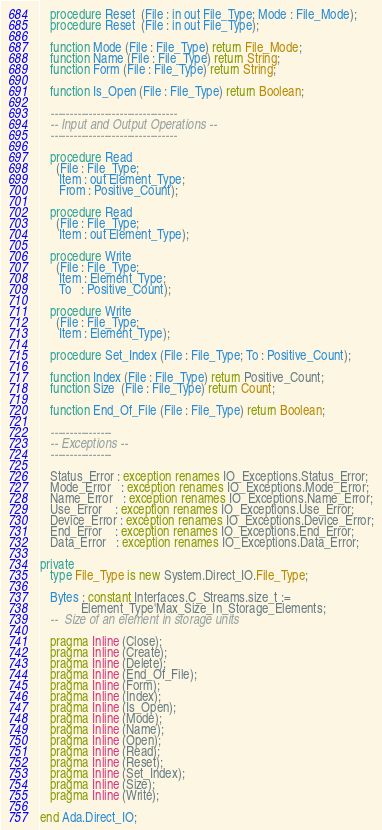<code> <loc_0><loc_0><loc_500><loc_500><_Ada_>   procedure Reset  (File : in out File_Type; Mode : File_Mode);
   procedure Reset  (File : in out File_Type);

   function Mode (File : File_Type) return File_Mode;
   function Name (File : File_Type) return String;
   function Form (File : File_Type) return String;

   function Is_Open (File : File_Type) return Boolean;

   ---------------------------------
   -- Input and Output Operations --
   ---------------------------------

   procedure Read
     (File : File_Type;
      Item : out Element_Type;
      From : Positive_Count);

   procedure Read
     (File : File_Type;
      Item : out Element_Type);

   procedure Write
     (File : File_Type;
      Item : Element_Type;
      To   : Positive_Count);

   procedure Write
     (File : File_Type;
      Item : Element_Type);

   procedure Set_Index (File : File_Type; To : Positive_Count);

   function Index (File : File_Type) return Positive_Count;
   function Size  (File : File_Type) return Count;

   function End_Of_File (File : File_Type) return Boolean;

   ----------------
   -- Exceptions --
   ----------------

   Status_Error : exception renames IO_Exceptions.Status_Error;
   Mode_Error   : exception renames IO_Exceptions.Mode_Error;
   Name_Error   : exception renames IO_Exceptions.Name_Error;
   Use_Error    : exception renames IO_Exceptions.Use_Error;
   Device_Error : exception renames IO_Exceptions.Device_Error;
   End_Error    : exception renames IO_Exceptions.End_Error;
   Data_Error   : exception renames IO_Exceptions.Data_Error;

private
   type File_Type is new System.Direct_IO.File_Type;

   Bytes : constant Interfaces.C_Streams.size_t :=
             Element_Type'Max_Size_In_Storage_Elements;
   --  Size of an element in storage units

   pragma Inline (Close);
   pragma Inline (Create);
   pragma Inline (Delete);
   pragma Inline (End_Of_File);
   pragma Inline (Form);
   pragma Inline (Index);
   pragma Inline (Is_Open);
   pragma Inline (Mode);
   pragma Inline (Name);
   pragma Inline (Open);
   pragma Inline (Read);
   pragma Inline (Reset);
   pragma Inline (Set_Index);
   pragma Inline (Size);
   pragma Inline (Write);

end Ada.Direct_IO;
</code> 